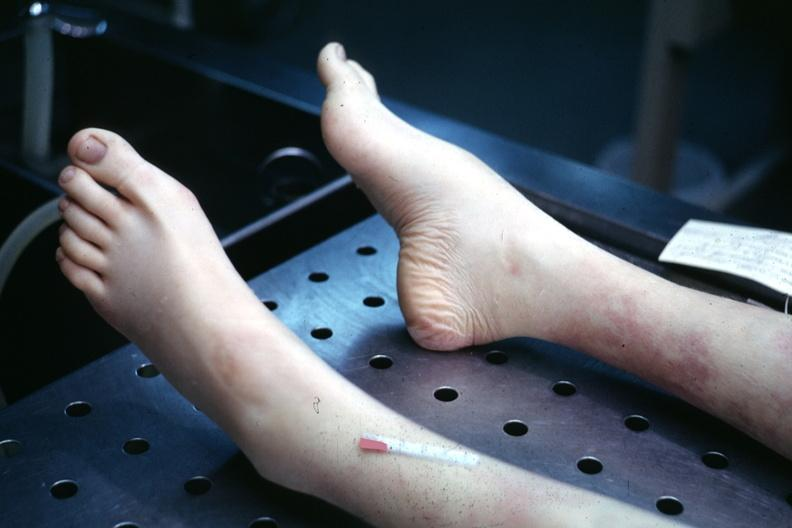does mucoepidermoid carcinoma show 22wf juvenile rheumatoid arthritis mild deformity with high arch?
Answer the question using a single word or phrase. No 